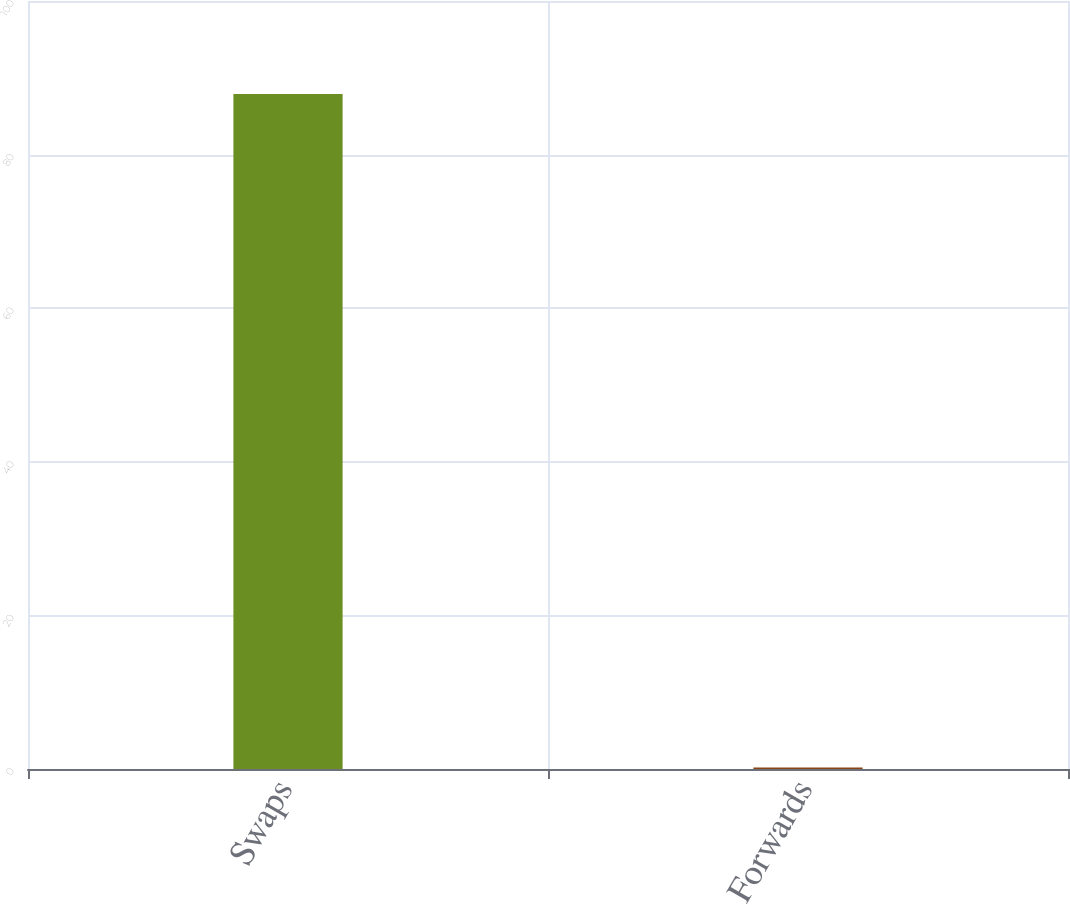Convert chart to OTSL. <chart><loc_0><loc_0><loc_500><loc_500><bar_chart><fcel>Swaps<fcel>Forwards<nl><fcel>87.9<fcel>0.2<nl></chart> 